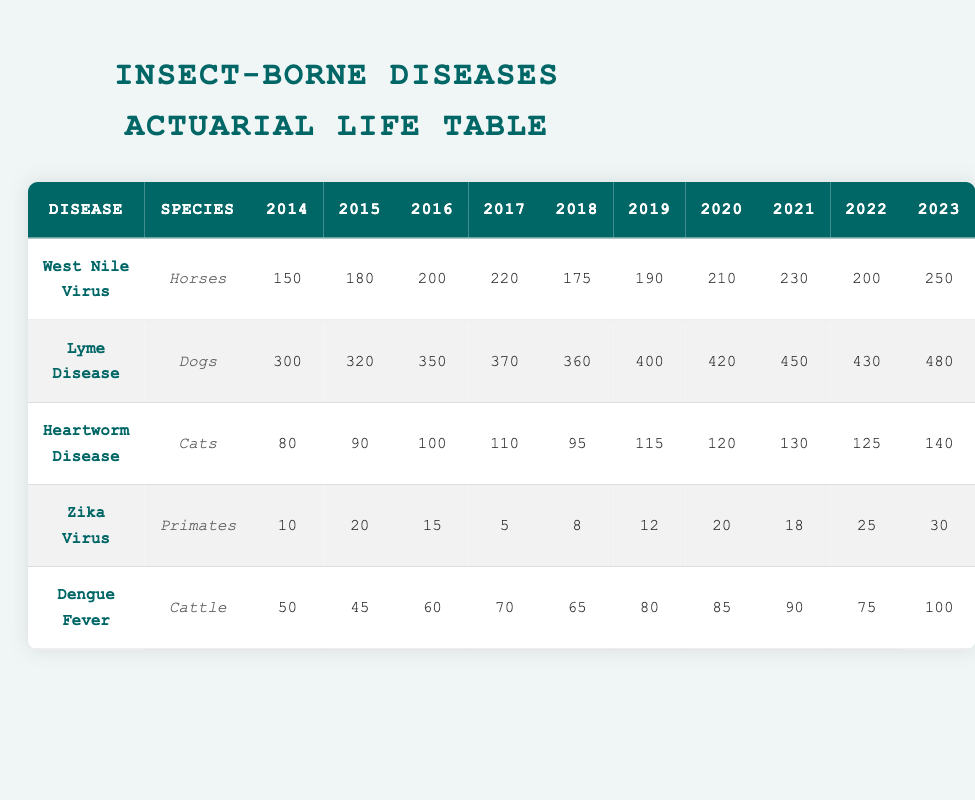What was the incidence of West Nile Virus in Horses in 2020? The table shows that the incidence of West Nile Virus in Horses for the year 2020 is listed in the corresponding cell, which contains the value 210.
Answer: 210 What is the total incidence of Lyme Disease in Dogs from 2014 to 2023? We need to add the values for each year from 2014 to 2023: 300 + 320 + 350 + 370 + 360 + 400 + 420 + 450 + 430 + 480. Summing these gives us a total of 4,680.
Answer: 4680 Did the incidence of Heartworm Disease in Cats increase from 2014 to 2023? Comparing the incidence in 2014 (80) and 2023 (140), we can see that the value in 2023 is greater than in 2014. Therefore, yes, it increased.
Answer: Yes Which insect-borne disease had the highest incidence in 2022? In 2022, Horses had 200 cases of West Nile Virus, Dogs had 430 cases of Lyme Disease, Cats had 125 cases of Heartworm Disease, Primates had 25 cases of Zika Virus, and Cattle had 75 cases of Dengue Fever. The highest incidence is from Dogs with 430 cases of Lyme Disease.
Answer: Lyme Disease What was the average incidence of Dengue Fever in Cattle over the decade? We calculate the average incidence by summing the values over the ten years: 50 + 45 + 60 + 70 + 65 + 80 + 85 + 90 + 75 + 100 = 750. Then, we divide by 10 (the number of years), which gives us an average of 75.
Answer: 75 Which animal species experienced the lowest incidence of any insect-borne disease in 2014? Looking at 2014, we have 150 cases for West Nile Virus in Horses, 300 for Lyme Disease in Dogs, 80 for Heartworm Disease in Cats, 10 for Zika Virus in Primates, and 50 for Dengue Fever in Cattle. The lowest incidence is in Primates with 10 cases of Zika Virus.
Answer: Primates How much did the incidence of Zika Virus in Primates decline from 2016 to 2017? The incidence was 15 in 2016 and decreased to 5 in 2017. The decline can be calculated by subtracting the two values: 15 - 5 = 10, showing a decrease of 10 cases.
Answer: 10 Which disease had a consistent increasing trend over the entire decade? Analyzing each disease, Lyme Disease shows a steady increase from 300 in 2014 to 480 in 2023 without any declines. No other disease had such a consistent increase.
Answer: Lyme Disease 